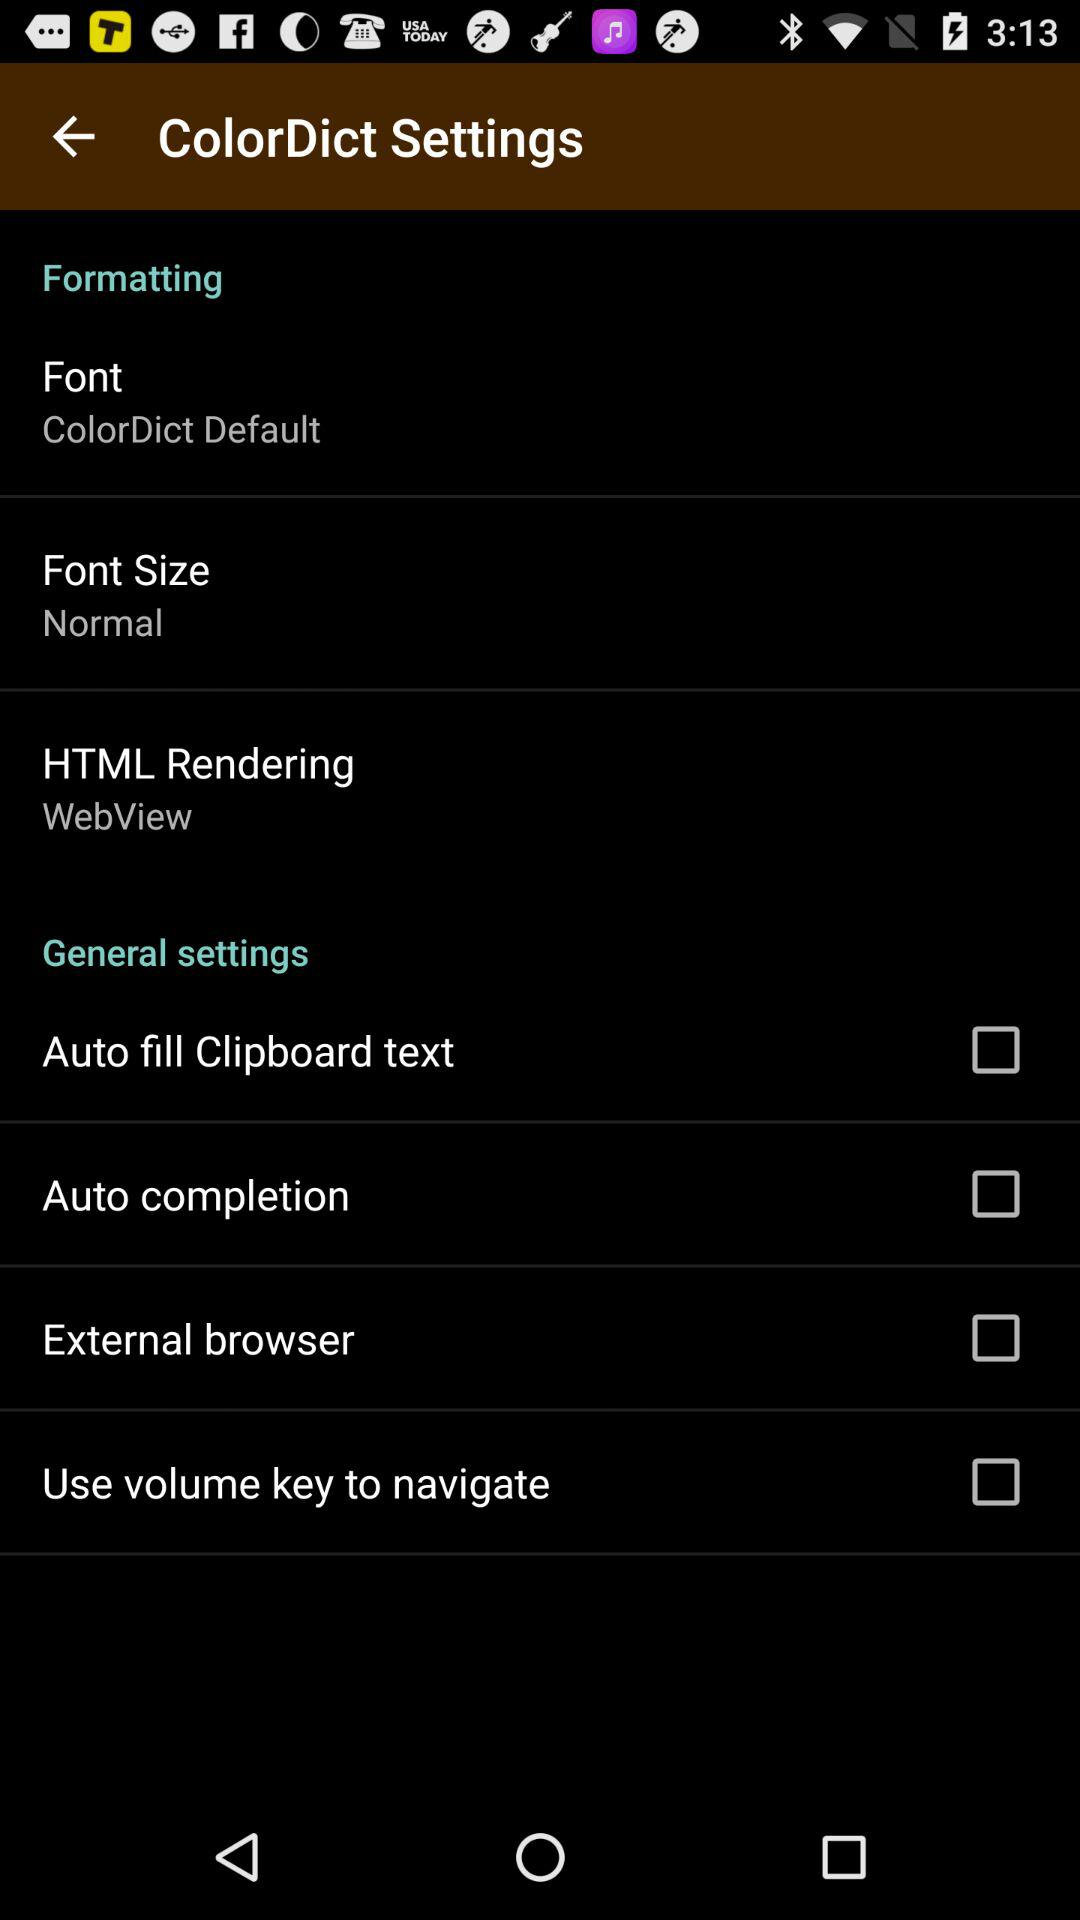What is the status of "Auto fill Clipboard text"? The status is "off". 